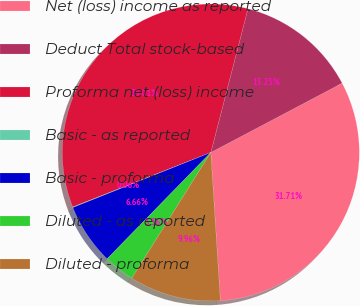Convert chart. <chart><loc_0><loc_0><loc_500><loc_500><pie_chart><fcel>Net (loss) income as reported<fcel>Deduct Total stock-based<fcel>Proforma net (loss) income<fcel>Basic - as reported<fcel>Basic - proforma<fcel>Diluted - as reported<fcel>Diluted - proforma<nl><fcel>31.71%<fcel>13.25%<fcel>35.01%<fcel>0.06%<fcel>6.66%<fcel>3.36%<fcel>9.96%<nl></chart> 